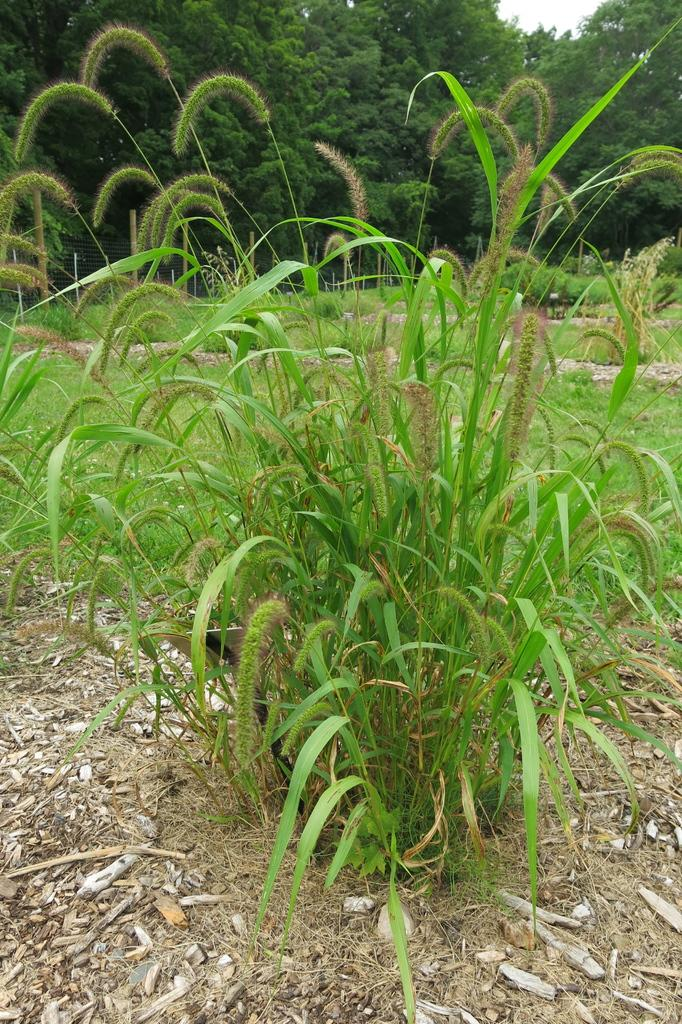What is the main subject of the image? There is a plant in the image. Can you describe the color of the plant? The plant is green in color. What can be seen in the background of the image? There are many trees visible in the background of the image. What is the color of the sky in the image? The sky is white in color. How many pets are visible in the image? There are no pets present in the image; it features a plant and trees in the background. What type of calculator is being used by the plant in the image? There is no calculator present in the image, as it features a plant and trees in the background. 